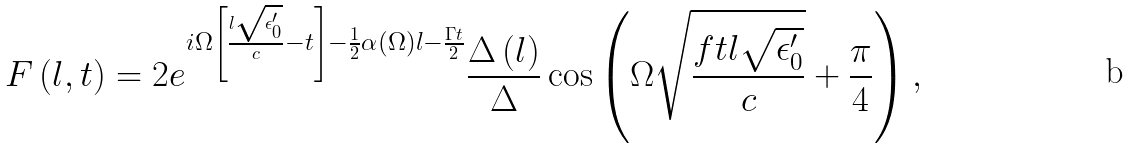Convert formula to latex. <formula><loc_0><loc_0><loc_500><loc_500>F \left ( l , t \right ) = 2 e ^ { i \Omega \left [ \frac { l \sqrt { \epsilon _ { 0 } ^ { \prime } } } { c } - t \right ] - \frac { 1 } { 2 } \alpha ( \Omega ) l - \frac { \Gamma t } { 2 } } \frac { \Delta \left ( l \right ) } { \Delta } \cos \left ( \Omega \sqrt { \frac { f t l \sqrt { \epsilon _ { 0 } ^ { \prime } } } { c } } + \frac { \pi } { 4 } \right ) ,</formula> 